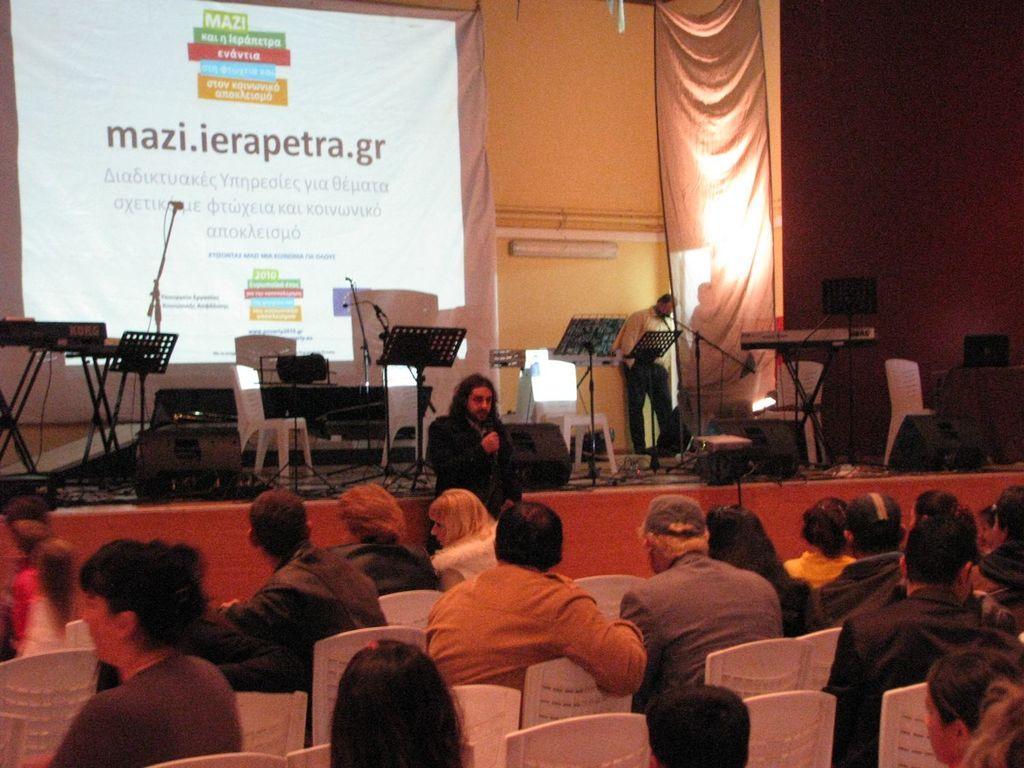How would you summarize this image in a sentence or two? In the foreground of the picture there are chairs and people. In the center of the picture there is a stage, on the stage there are stands, stools, people, mic, cables, speakers, chairs, banner, curtain, text and other objects. In the center of the picture there is a person holding mic. 